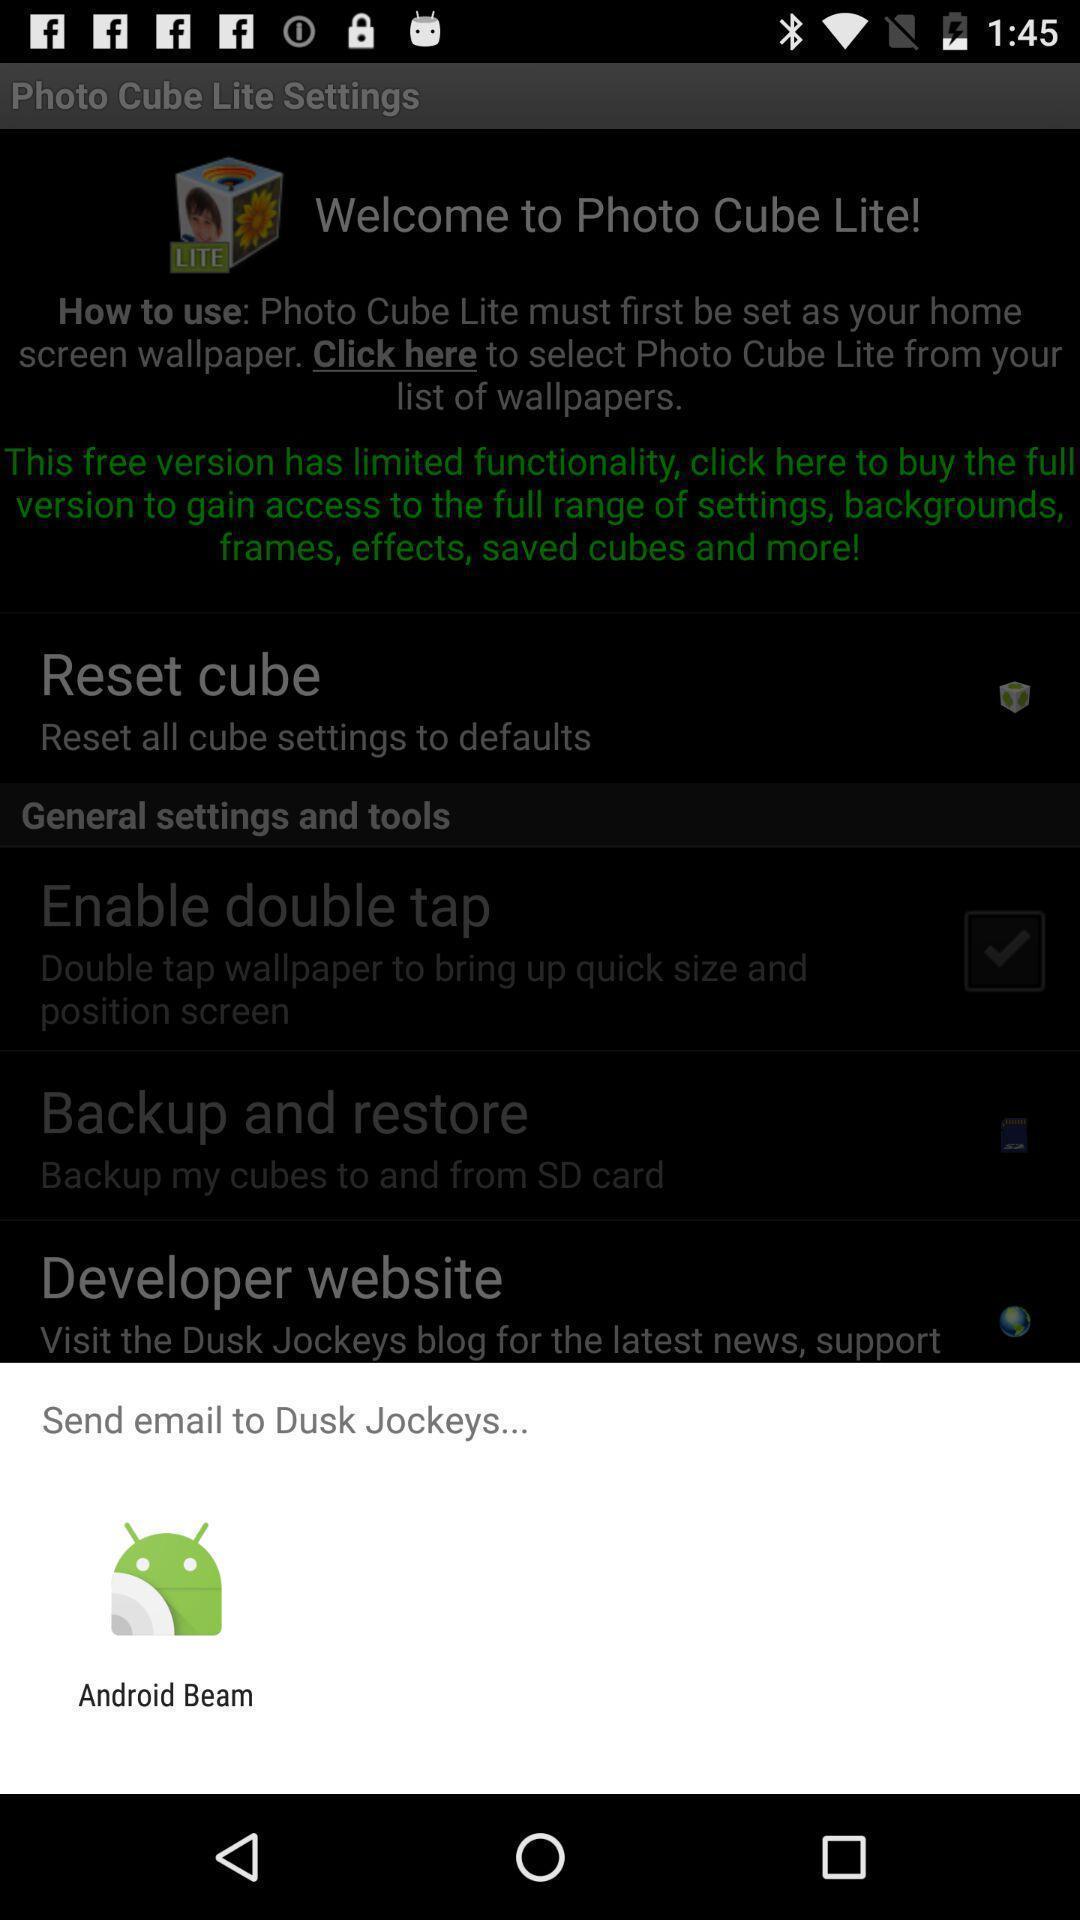Give me a summary of this screen capture. Push up message for sending mail via social network. 